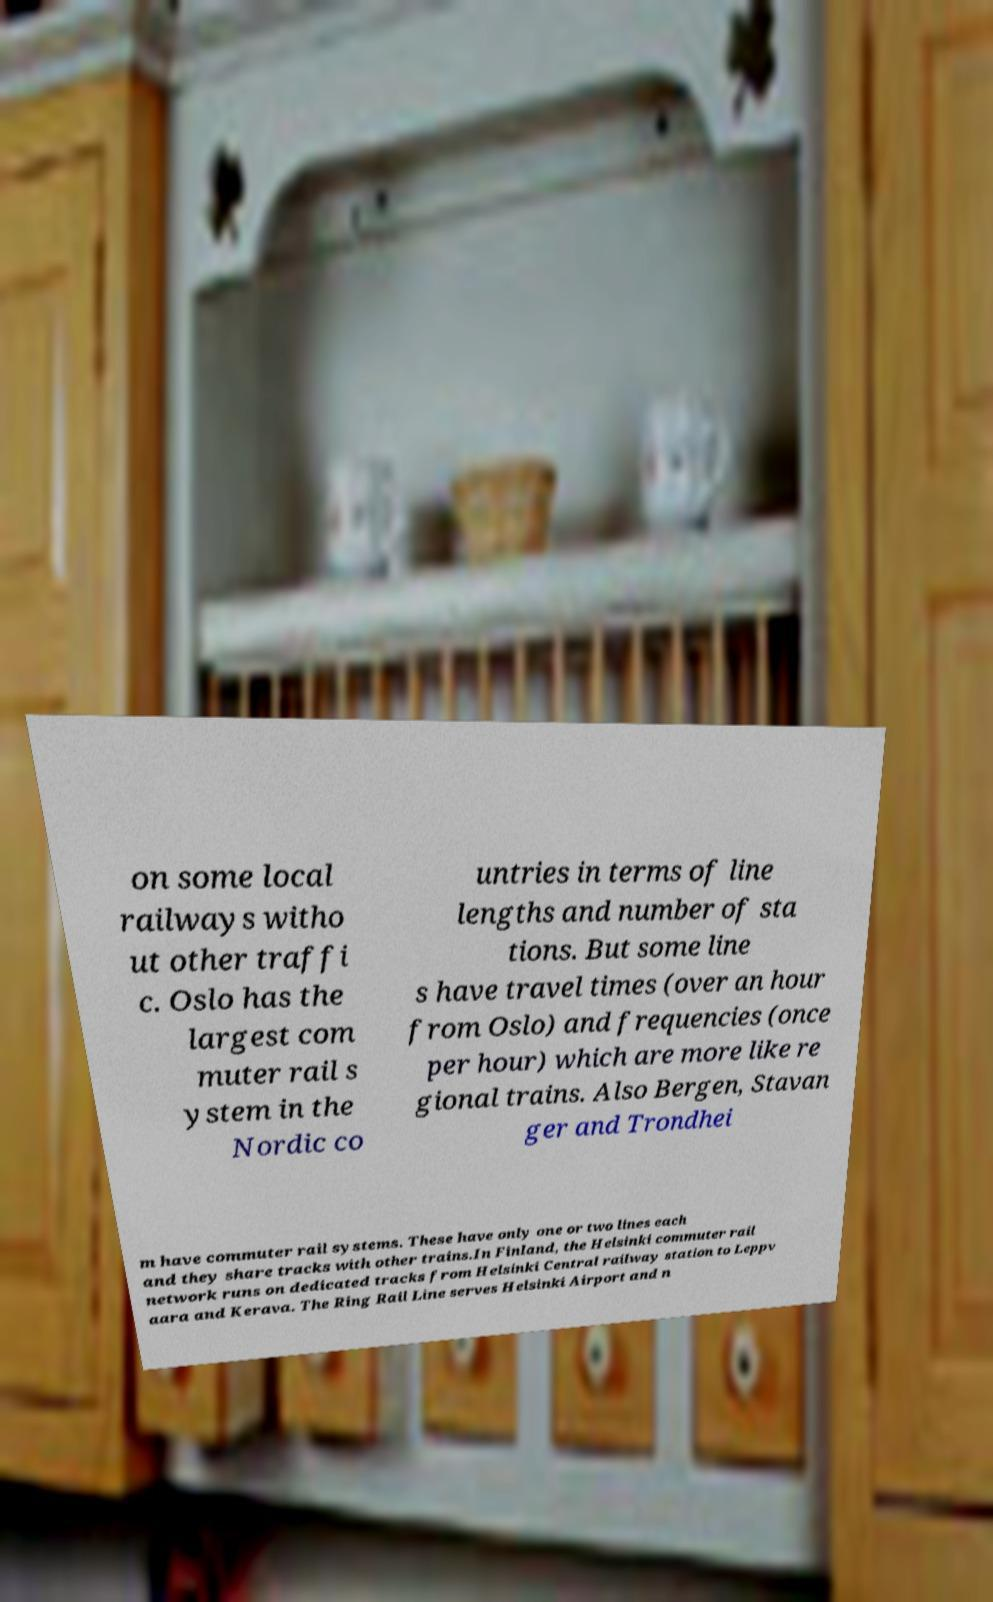Could you extract and type out the text from this image? on some local railways witho ut other traffi c. Oslo has the largest com muter rail s ystem in the Nordic co untries in terms of line lengths and number of sta tions. But some line s have travel times (over an hour from Oslo) and frequencies (once per hour) which are more like re gional trains. Also Bergen, Stavan ger and Trondhei m have commuter rail systems. These have only one or two lines each and they share tracks with other trains.In Finland, the Helsinki commuter rail network runs on dedicated tracks from Helsinki Central railway station to Leppv aara and Kerava. The Ring Rail Line serves Helsinki Airport and n 